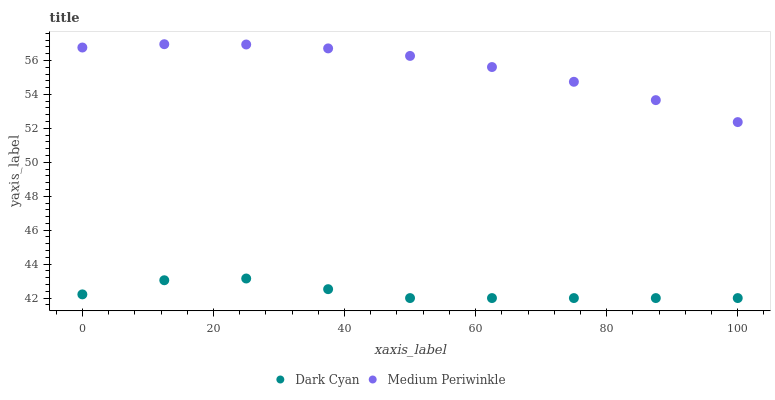Does Dark Cyan have the minimum area under the curve?
Answer yes or no. Yes. Does Medium Periwinkle have the maximum area under the curve?
Answer yes or no. Yes. Does Medium Periwinkle have the minimum area under the curve?
Answer yes or no. No. Is Medium Periwinkle the smoothest?
Answer yes or no. Yes. Is Dark Cyan the roughest?
Answer yes or no. Yes. Is Medium Periwinkle the roughest?
Answer yes or no. No. Does Dark Cyan have the lowest value?
Answer yes or no. Yes. Does Medium Periwinkle have the lowest value?
Answer yes or no. No. Does Medium Periwinkle have the highest value?
Answer yes or no. Yes. Is Dark Cyan less than Medium Periwinkle?
Answer yes or no. Yes. Is Medium Periwinkle greater than Dark Cyan?
Answer yes or no. Yes. Does Dark Cyan intersect Medium Periwinkle?
Answer yes or no. No. 